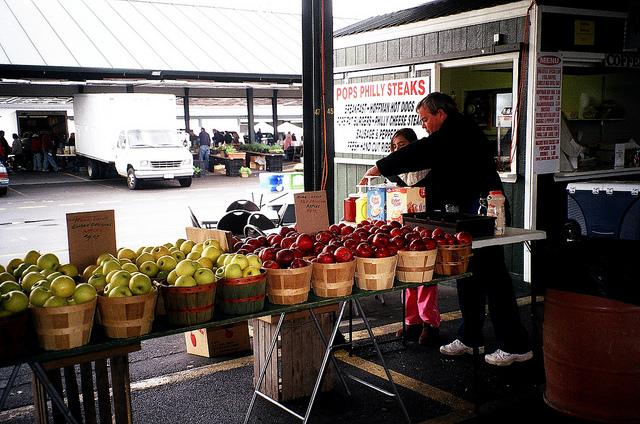What color are the apples?
Keep it brief. Red and green. How many baskets of fruit are there?
Answer briefly. 20. What sandwich does this deli feature?
Short answer required. Philly steak. 